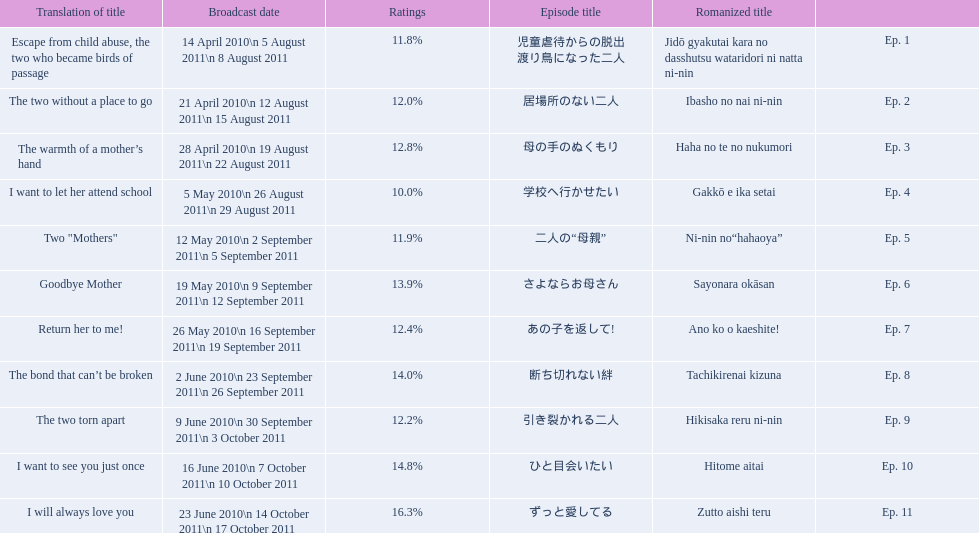What was the best-rated episode of this series? ずっと愛してる. 